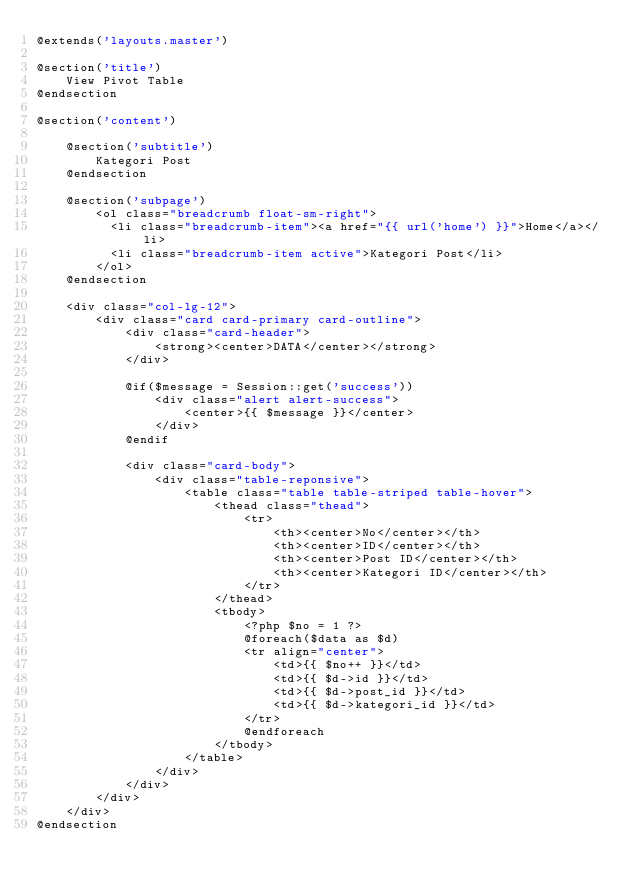<code> <loc_0><loc_0><loc_500><loc_500><_PHP_>@extends('layouts.master')

@section('title')
    View Pivot Table
@endsection

@section('content')

    @section('subtitle')
        Kategori Post
    @endsection

    @section('subpage')
        <ol class="breadcrumb float-sm-right">
          <li class="breadcrumb-item"><a href="{{ url('home') }}">Home</a></li>
          <li class="breadcrumb-item active">Kategori Post</li>
        </ol>
    @endsection

    <div class="col-lg-12">
        <div class="card card-primary card-outline">
            <div class="card-header">
                <strong><center>DATA</center></strong>
            </div>

            @if($message = Session::get('success'))
                <div class="alert alert-success">
                    <center>{{ $message }}</center>
                </div>
            @endif

            <div class="card-body">
                <div class="table-reponsive">
                    <table class="table table-striped table-hover">
                        <thead class="thead">
                            <tr>
                                <th><center>No</center></th>
                                <th><center>ID</center></th>
                                <th><center>Post ID</center></th>
                                <th><center>Kategori ID</center></th>
                            </tr>
                        </thead>
                        <tbody>
                            <?php $no = 1 ?>
                            @foreach($data as $d)
                            <tr align="center">
                                <td>{{ $no++ }}</td>
                                <td>{{ $d->id }}</td>
                                <td>{{ $d->post_id }}</td>
                                <td>{{ $d->kategori_id }}</td>
                            </tr>
                            @endforeach
                        </tbody>
                    </table>
                </div>
            </div>
        </div>
    </div>
@endsection
</code> 